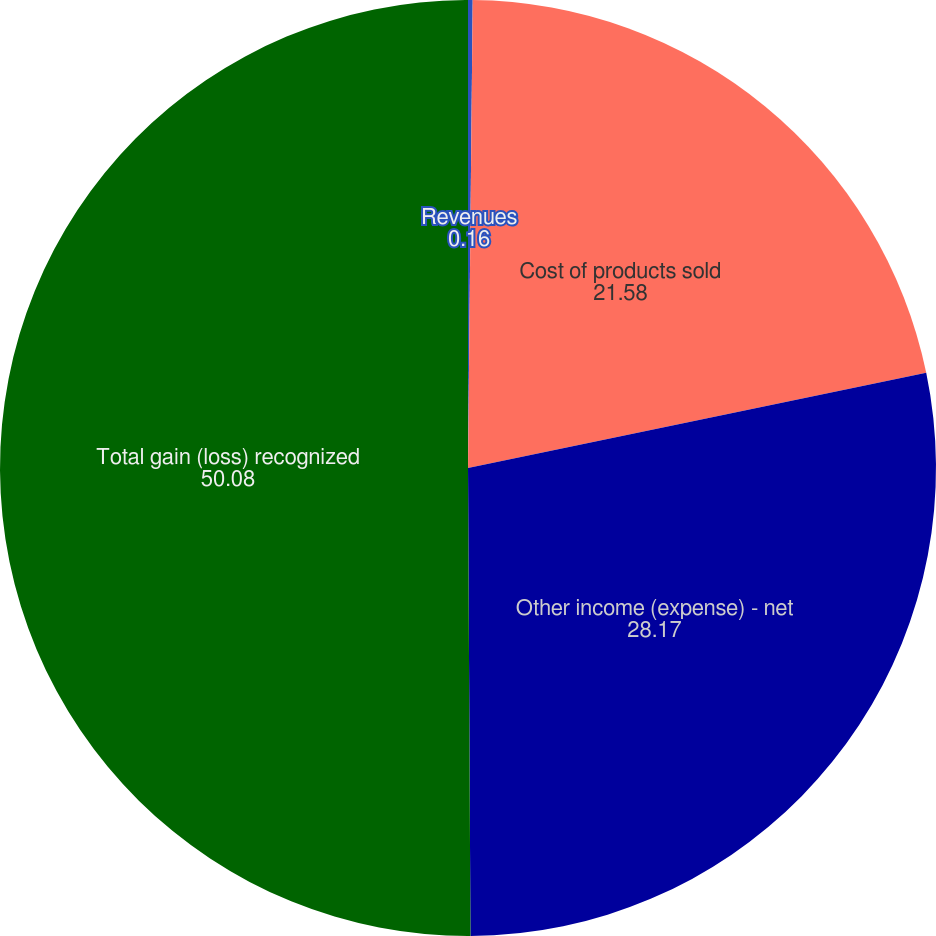<chart> <loc_0><loc_0><loc_500><loc_500><pie_chart><fcel>Revenues<fcel>Cost of products sold<fcel>Other income (expense) - net<fcel>Total gain (loss) recognized<nl><fcel>0.16%<fcel>21.58%<fcel>28.17%<fcel>50.08%<nl></chart> 